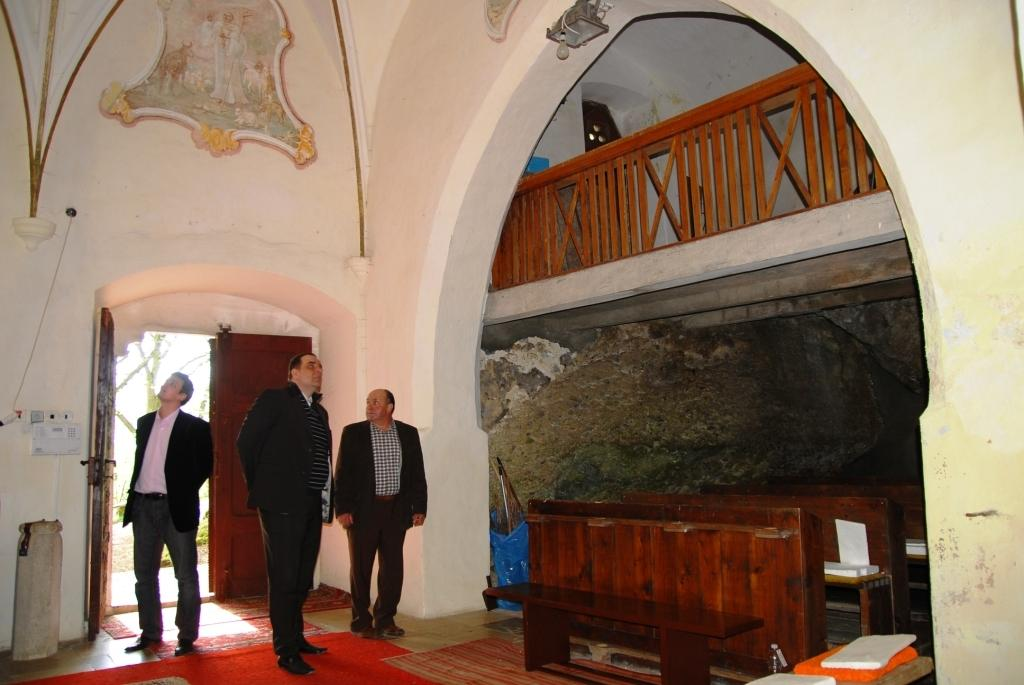What type of structure can be seen in the image? There is an arch in the image. What is another feature that can be seen in the image? There is a fence in the image. Can you describe the wooden object in the image? There is a wooden object in the image. Are there any people present in the image? Yes, there are people in the image. What is the purpose of the door in the image? There is a door in the image. What is placed near the entrance in the image? There is a floor mat in the image. What other objects can be seen in the image? There are other objects in the image. What type of secretary can be seen in the image? There is no secretary present in the image. 